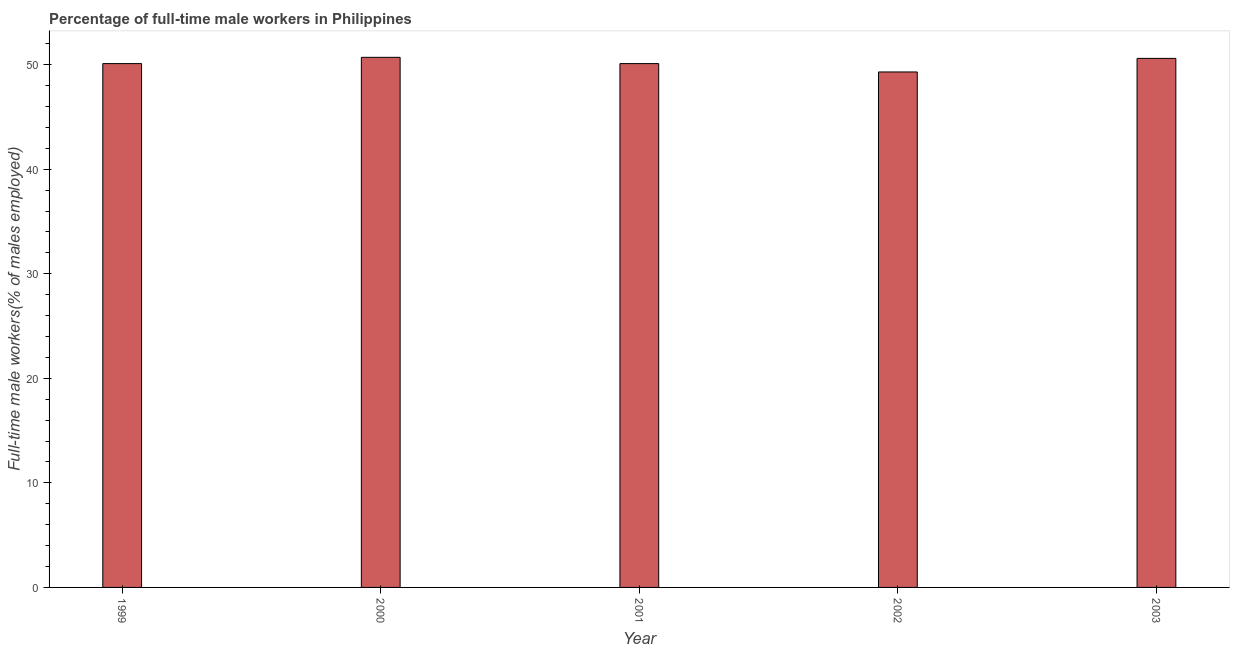Does the graph contain grids?
Make the answer very short. No. What is the title of the graph?
Your answer should be compact. Percentage of full-time male workers in Philippines. What is the label or title of the X-axis?
Your response must be concise. Year. What is the label or title of the Y-axis?
Keep it short and to the point. Full-time male workers(% of males employed). What is the percentage of full-time male workers in 2001?
Your answer should be compact. 50.1. Across all years, what is the maximum percentage of full-time male workers?
Offer a terse response. 50.7. Across all years, what is the minimum percentage of full-time male workers?
Give a very brief answer. 49.3. In which year was the percentage of full-time male workers maximum?
Keep it short and to the point. 2000. What is the sum of the percentage of full-time male workers?
Offer a very short reply. 250.8. What is the average percentage of full-time male workers per year?
Offer a very short reply. 50.16. What is the median percentage of full-time male workers?
Offer a terse response. 50.1. Do a majority of the years between 1999 and 2001 (inclusive) have percentage of full-time male workers greater than 44 %?
Provide a short and direct response. Yes. Is the difference between the percentage of full-time male workers in 2002 and 2003 greater than the difference between any two years?
Your response must be concise. No. What is the difference between the highest and the second highest percentage of full-time male workers?
Make the answer very short. 0.1. What is the difference between the highest and the lowest percentage of full-time male workers?
Your response must be concise. 1.4. Are all the bars in the graph horizontal?
Provide a short and direct response. No. How many years are there in the graph?
Offer a terse response. 5. Are the values on the major ticks of Y-axis written in scientific E-notation?
Your response must be concise. No. What is the Full-time male workers(% of males employed) of 1999?
Your response must be concise. 50.1. What is the Full-time male workers(% of males employed) of 2000?
Provide a succinct answer. 50.7. What is the Full-time male workers(% of males employed) in 2001?
Keep it short and to the point. 50.1. What is the Full-time male workers(% of males employed) of 2002?
Make the answer very short. 49.3. What is the Full-time male workers(% of males employed) of 2003?
Make the answer very short. 50.6. What is the difference between the Full-time male workers(% of males employed) in 1999 and 2001?
Give a very brief answer. 0. What is the difference between the Full-time male workers(% of males employed) in 1999 and 2003?
Provide a succinct answer. -0.5. What is the difference between the Full-time male workers(% of males employed) in 2000 and 2001?
Make the answer very short. 0.6. What is the difference between the Full-time male workers(% of males employed) in 2002 and 2003?
Ensure brevity in your answer.  -1.3. What is the ratio of the Full-time male workers(% of males employed) in 1999 to that in 2000?
Provide a succinct answer. 0.99. What is the ratio of the Full-time male workers(% of males employed) in 1999 to that in 2002?
Give a very brief answer. 1.02. What is the ratio of the Full-time male workers(% of males employed) in 2000 to that in 2001?
Give a very brief answer. 1.01. What is the ratio of the Full-time male workers(% of males employed) in 2000 to that in 2002?
Ensure brevity in your answer.  1.03. What is the ratio of the Full-time male workers(% of males employed) in 2000 to that in 2003?
Give a very brief answer. 1. What is the ratio of the Full-time male workers(% of males employed) in 2001 to that in 2003?
Make the answer very short. 0.99. 